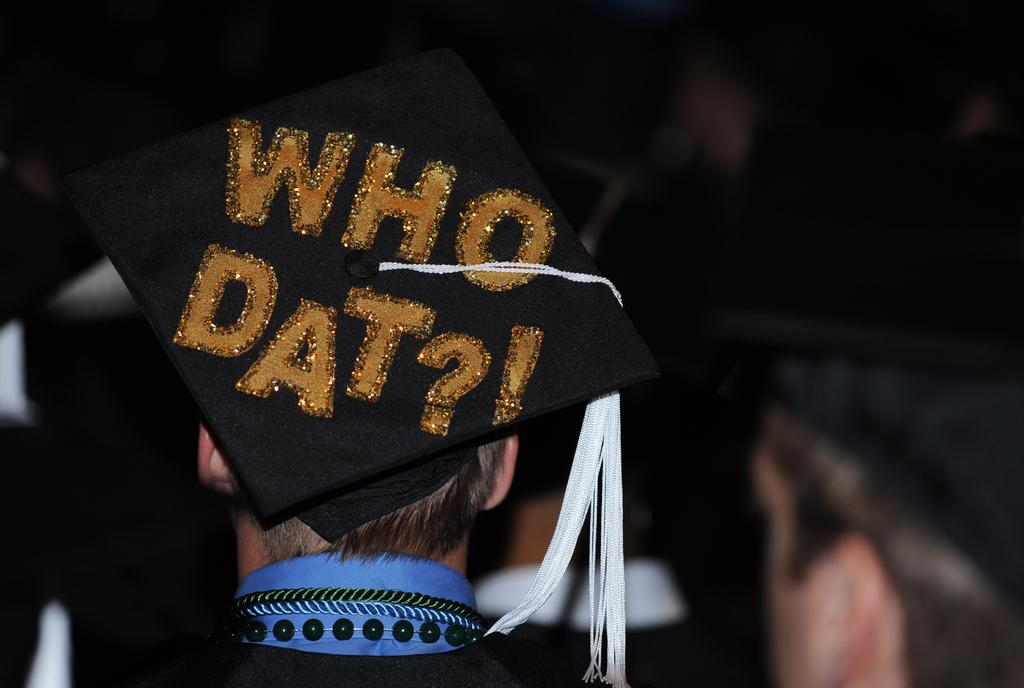What is the main subject of the image? There is a person standing in the image. What is the person wearing on their head? The person is wearing a convocation cap on their head. What can be seen on the convocation cap? There is text on the convocation cap. What type of coat is the person wearing in the image? There is no coat visible in the image; the person is wearing a convocation cap. Can you see a brush in the person's hand in the image? There is no brush present in the image. 